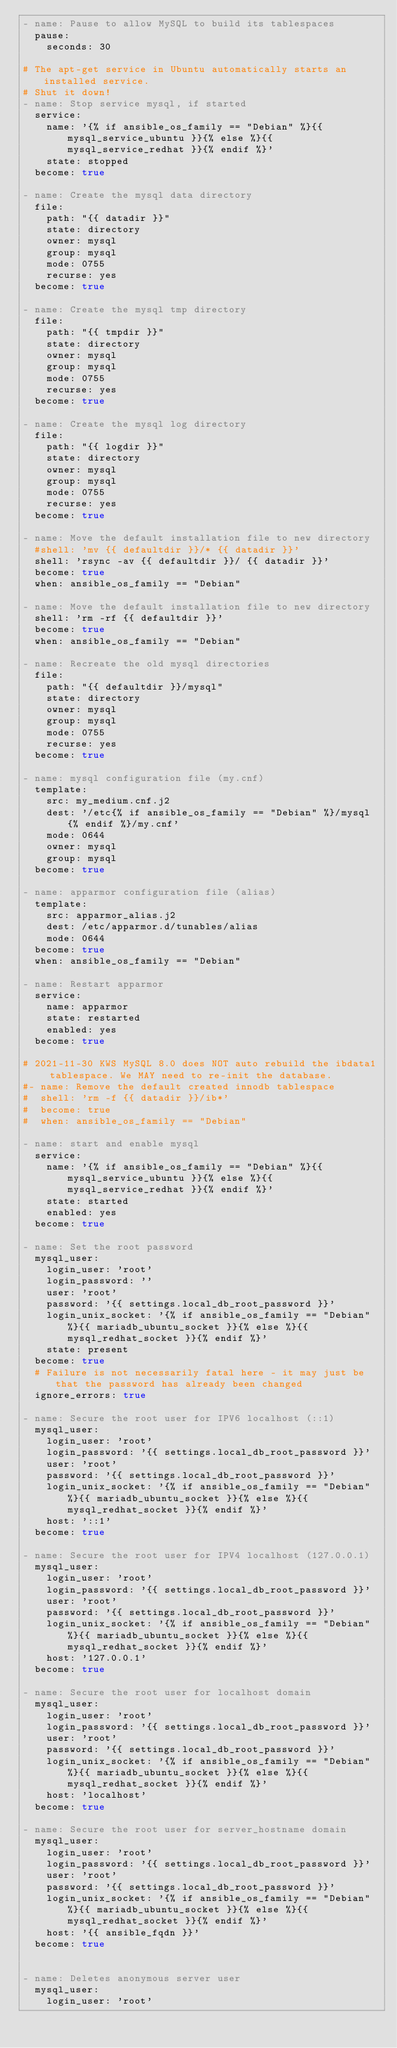Convert code to text. <code><loc_0><loc_0><loc_500><loc_500><_YAML_>- name: Pause to allow MySQL to build its tablespaces
  pause:
    seconds: 30

# The apt-get service in Ubuntu automatically starts an installed service.
# Shut it down!
- name: Stop service mysql, if started
  service:
    name: '{% if ansible_os_family == "Debian" %}{{ mysql_service_ubuntu }}{% else %}{{ mysql_service_redhat }}{% endif %}'
    state: stopped
  become: true

- name: Create the mysql data directory
  file:
    path: "{{ datadir }}"
    state: directory
    owner: mysql
    group: mysql
    mode: 0755
    recurse: yes
  become: true

- name: Create the mysql tmp directory
  file:
    path: "{{ tmpdir }}"
    state: directory
    owner: mysql
    group: mysql
    mode: 0755
    recurse: yes
  become: true

- name: Create the mysql log directory
  file:
    path: "{{ logdir }}"
    state: directory
    owner: mysql
    group: mysql
    mode: 0755
    recurse: yes
  become: true

- name: Move the default installation file to new directory
  #shell: 'mv {{ defaultdir }}/* {{ datadir }}'
  shell: 'rsync -av {{ defaultdir }}/ {{ datadir }}'
  become: true
  when: ansible_os_family == "Debian"

- name: Move the default installation file to new directory
  shell: 'rm -rf {{ defaultdir }}'
  become: true
  when: ansible_os_family == "Debian"

- name: Recreate the old mysql directories
  file:
    path: "{{ defaultdir }}/mysql"
    state: directory
    owner: mysql
    group: mysql
    mode: 0755
    recurse: yes
  become: true

- name: mysql configuration file (my.cnf)
  template:
    src: my_medium.cnf.j2
    dest: '/etc{% if ansible_os_family == "Debian" %}/mysql{% endif %}/my.cnf'
    mode: 0644
    owner: mysql
    group: mysql
  become: true

- name: apparmor configuration file (alias)
  template:
    src: apparmor_alias.j2
    dest: /etc/apparmor.d/tunables/alias
    mode: 0644
  become: true
  when: ansible_os_family == "Debian"

- name: Restart apparmor
  service:
    name: apparmor
    state: restarted
    enabled: yes
  become: true

# 2021-11-30 KWS MySQL 8.0 does NOT auto rebuild the ibdata1 tablespace. We MAY need to re-init the database.
#- name: Remove the default created innodb tablespace 
#  shell: 'rm -f {{ datadir }}/ib*'
#  become: true
#  when: ansible_os_family == "Debian"

- name: start and enable mysql
  service:
    name: '{% if ansible_os_family == "Debian" %}{{ mysql_service_ubuntu }}{% else %}{{ mysql_service_redhat }}{% endif %}'
    state: started
    enabled: yes
  become: true

- name: Set the root password
  mysql_user:
    login_user: 'root'
    login_password: ''
    user: 'root'
    password: '{{ settings.local_db_root_password }}'
    login_unix_socket: '{% if ansible_os_family == "Debian" %}{{ mariadb_ubuntu_socket }}{% else %}{{ mysql_redhat_socket }}{% endif %}'
    state: present
  become: true
  # Failure is not necessarily fatal here - it may just be that the password has already been changed
  ignore_errors: true

- name: Secure the root user for IPV6 localhost (::1)
  mysql_user:
    login_user: 'root'
    login_password: '{{ settings.local_db_root_password }}'
    user: 'root'
    password: '{{ settings.local_db_root_password }}'
    login_unix_socket: '{% if ansible_os_family == "Debian" %}{{ mariadb_ubuntu_socket }}{% else %}{{ mysql_redhat_socket }}{% endif %}'
    host: '::1'
  become: true

- name: Secure the root user for IPV4 localhost (127.0.0.1)
  mysql_user:
    login_user: 'root'
    login_password: '{{ settings.local_db_root_password }}'
    user: 'root'
    password: '{{ settings.local_db_root_password }}'
    login_unix_socket: '{% if ansible_os_family == "Debian" %}{{ mariadb_ubuntu_socket }}{% else %}{{ mysql_redhat_socket }}{% endif %}'
    host: '127.0.0.1'
  become: true

- name: Secure the root user for localhost domain
  mysql_user:
    login_user: 'root'
    login_password: '{{ settings.local_db_root_password }}'
    user: 'root'
    password: '{{ settings.local_db_root_password }}'
    login_unix_socket: '{% if ansible_os_family == "Debian" %}{{ mariadb_ubuntu_socket }}{% else %}{{ mysql_redhat_socket }}{% endif %}'
    host: 'localhost'
  become: true

- name: Secure the root user for server_hostname domain
  mysql_user:
    login_user: 'root'
    login_password: '{{ settings.local_db_root_password }}'
    user: 'root'
    password: '{{ settings.local_db_root_password }}'
    login_unix_socket: '{% if ansible_os_family == "Debian" %}{{ mariadb_ubuntu_socket }}{% else %}{{ mysql_redhat_socket }}{% endif %}'
    host: '{{ ansible_fqdn }}'
  become: true


- name: Deletes anonymous server user
  mysql_user:
    login_user: 'root'</code> 